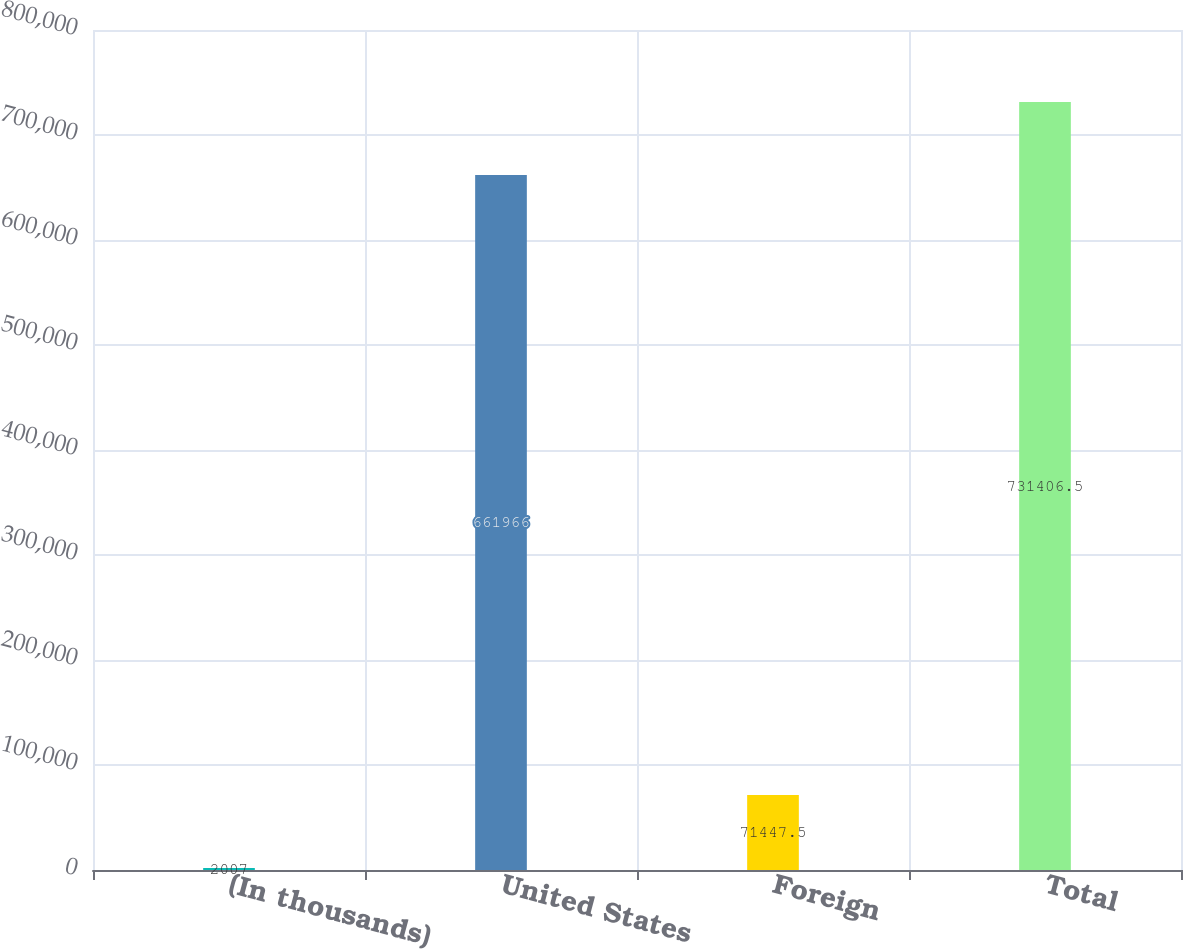Convert chart to OTSL. <chart><loc_0><loc_0><loc_500><loc_500><bar_chart><fcel>(In thousands)<fcel>United States<fcel>Foreign<fcel>Total<nl><fcel>2007<fcel>661966<fcel>71447.5<fcel>731406<nl></chart> 